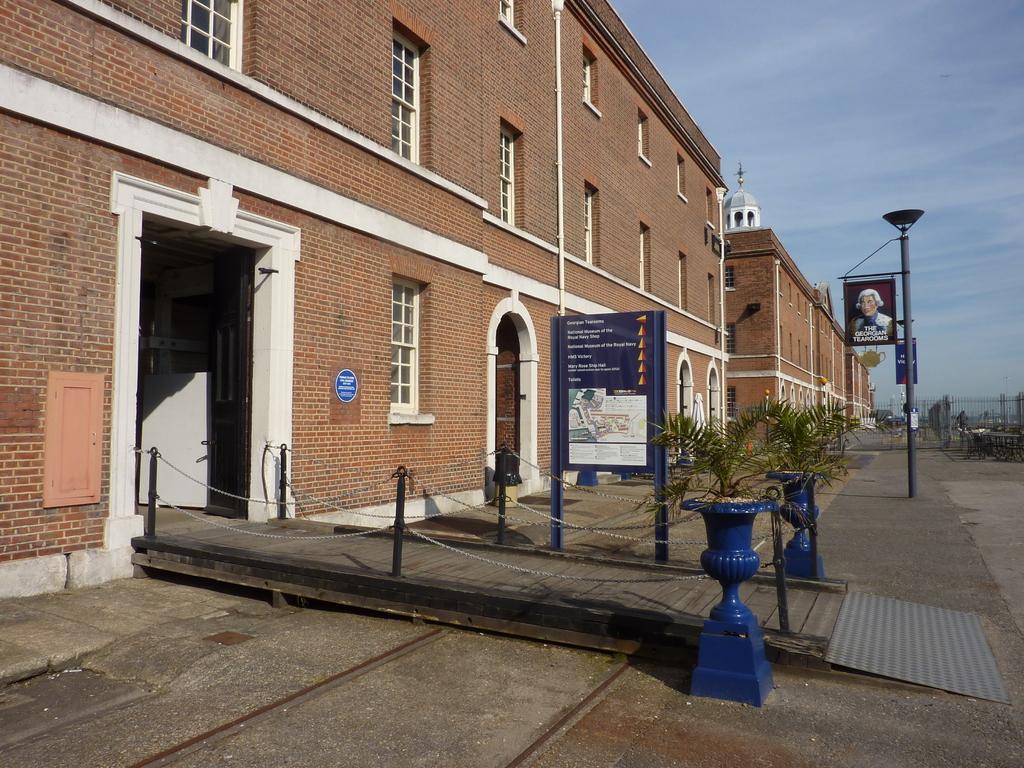Could you give a brief overview of what you see in this image? In the picture we can see buildings with windows and near to it we can see a path with some plants and poles and in the background we can see a sky. 